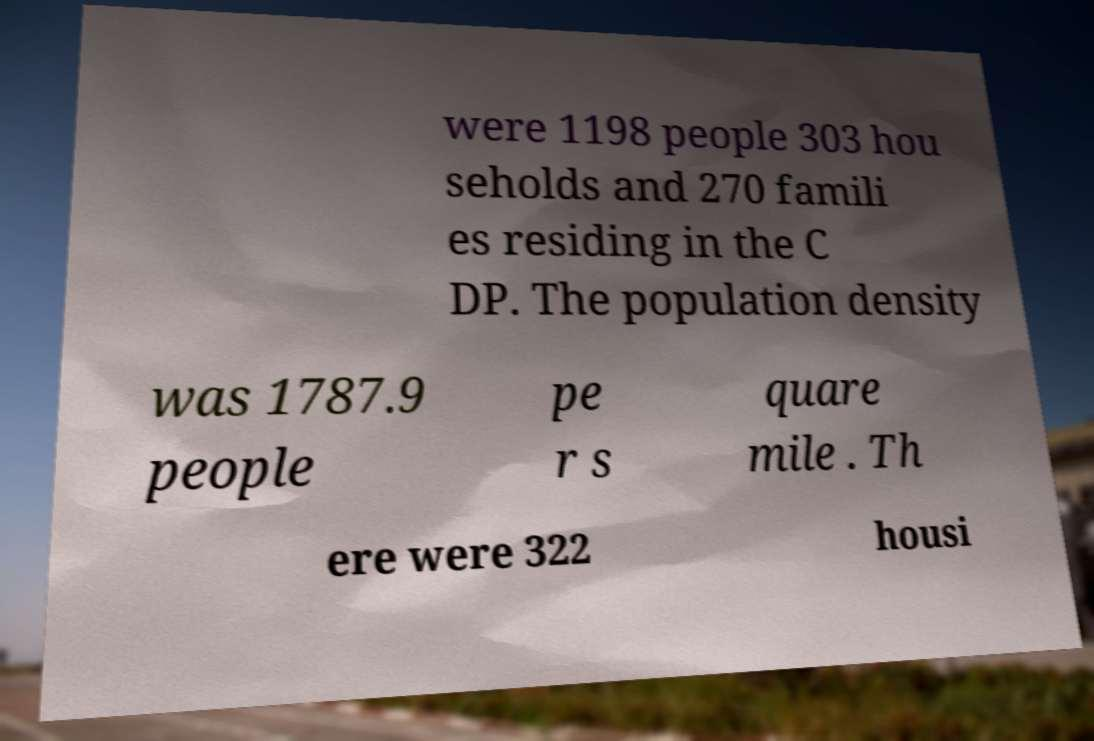Can you accurately transcribe the text from the provided image for me? were 1198 people 303 hou seholds and 270 famili es residing in the C DP. The population density was 1787.9 people pe r s quare mile . Th ere were 322 housi 